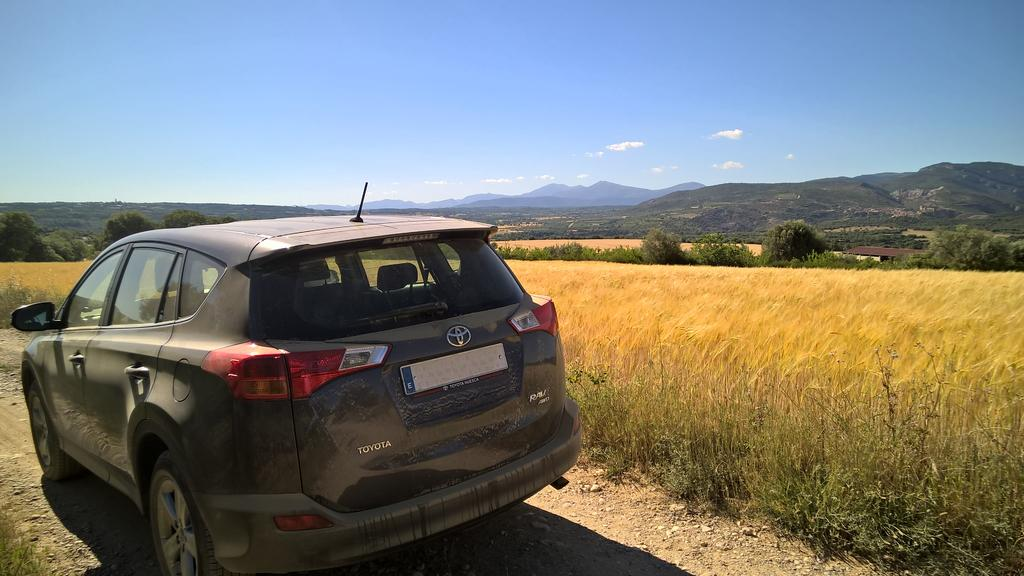What is the main subject of the image? There is a car in the image. What type of terrain is visible in the image? There is grass in the image. What can be seen in the background of the image? There are trees and a mountain in the background of the image. What is visible in the sky in the image? The sky is visible in the background of the image, and clouds are present. Where is the stove located in the image? There is no stove present in the image. What type of cap is the deer wearing in the image? There is no deer or cap present in the image. 